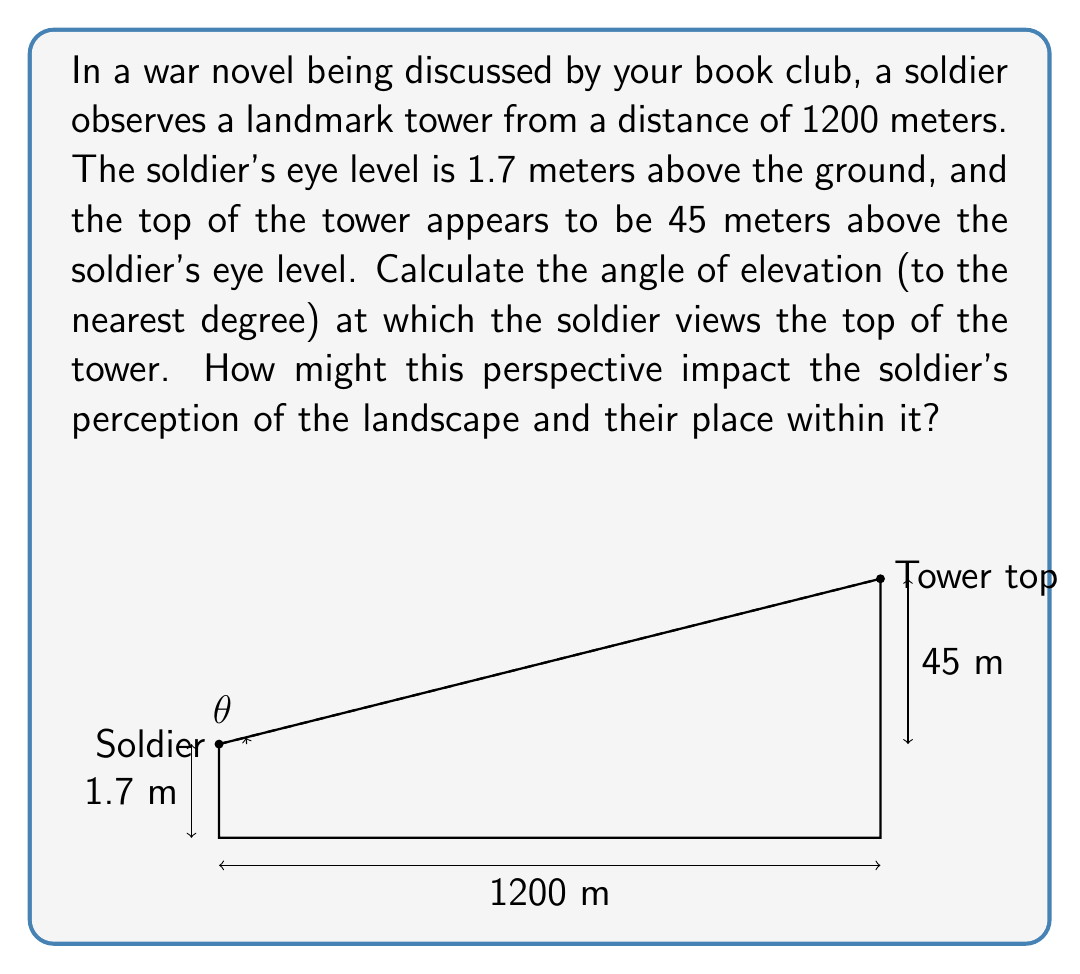Help me with this question. To solve this problem, we'll use trigonometry, specifically the tangent function. Let's break it down step-by-step:

1) First, let's identify the triangle we're working with. The soldier's eye level forms the base of a right-angled triangle, with the tower forming the opposite side and the line of sight forming the hypotenuse.

2) We need to find the angle of elevation, which is the angle between the horizontal (soldier's eye level) and the line of sight to the top of the tower.

3) In a right-angled triangle, tangent of an angle is the ratio of the opposite side to the adjacent side.

   $\tan(\theta) = \frac{\text{opposite}}{\text{adjacent}}$

4) In our case:
   - The opposite side is the height difference between the soldier's eye level and the top of the tower: 45 meters
   - The adjacent side is the horizontal distance: 1200 meters

5) Let's plug these into our tangent formula:

   $\tan(\theta) = \frac{45}{1200}$

6) To find the angle, we need to use the inverse tangent (arctan or $\tan^{-1}$):

   $\theta = \tan^{-1}(\frac{45}{1200})$

7) Using a calculator or computer:

   $\theta \approx 2.1466$ degrees

8) Rounding to the nearest degree as requested:

   $\theta \approx 2$ degrees

This low angle of elevation might impact the soldier's perception by emphasizing the vast distance and open space between them and the landmark, potentially evoking feelings of vulnerability or isolation in the war-torn landscape.
Answer: The angle of elevation is approximately 2 degrees. 